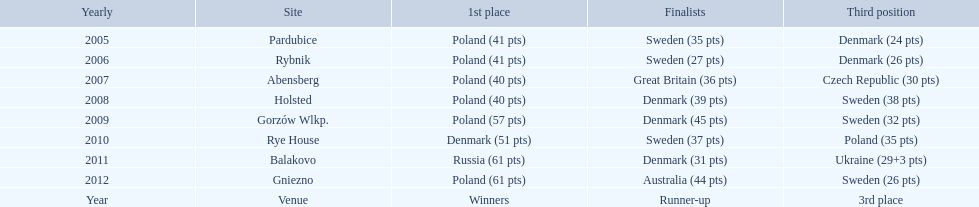Did holland win the 2010 championship? if not who did? Rye House. What did position did holland they rank? 3rd place. 